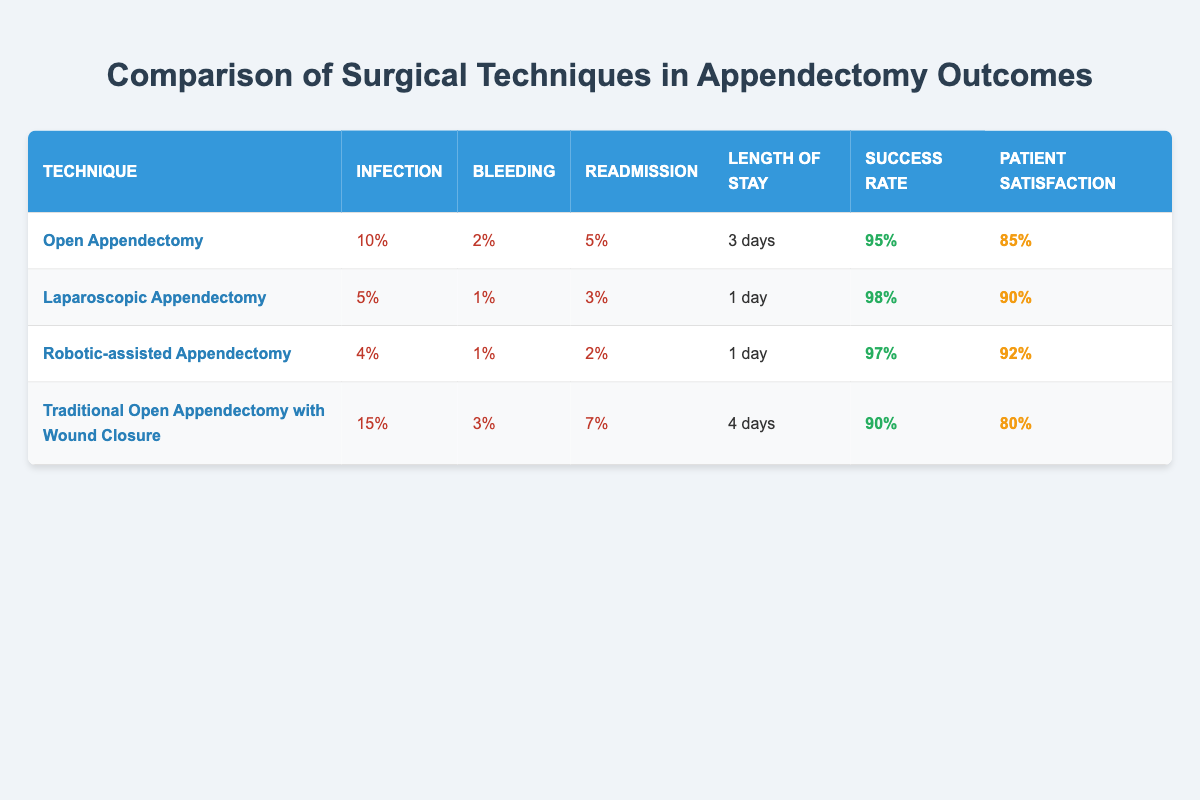What is the infection rate for Laparoscopic Appendectomy? The table shows that the infection rate for Laparoscopic Appendectomy is listed under the "Infection" column for that technique. It states "5%".
Answer: 5% Which surgical technique has the highest overall success rate? By comparing the "Success Rate" column, Laparoscopic Appendectomy has the highest rate at "98%".
Answer: Laparoscopic Appendectomy What is the average length of stay for all surgical techniques? The lengths of stay are 3 days for Open, 1 day for Laparoscopic, 1 day for Robotic-assisted, and 4 days for Traditional Open. Adding these gives (3 + 1 + 1 + 4) = 9 days, and dividing by 4 (the number of techniques) gives an average of 2.25 days.
Answer: 2.25 days Is it true that Robotic-assisted Appendectomy has a lower readmission rate than Open Appendectomy? The table lists the readmission rate for Robotic-assisted as "2%" and for Open Appendectomy as "5%". Since 2% is less than 5%, the statement is true.
Answer: Yes What is the difference in patient satisfaction between the Laparoscopic Appendectomy and Traditional Open Appendectomy with Wound Closure? Patient satisfaction for Laparoscopic is "90%" and for Traditional Open is "80%". The difference is calculated as (90% - 80%) = 10%.
Answer: 10% 